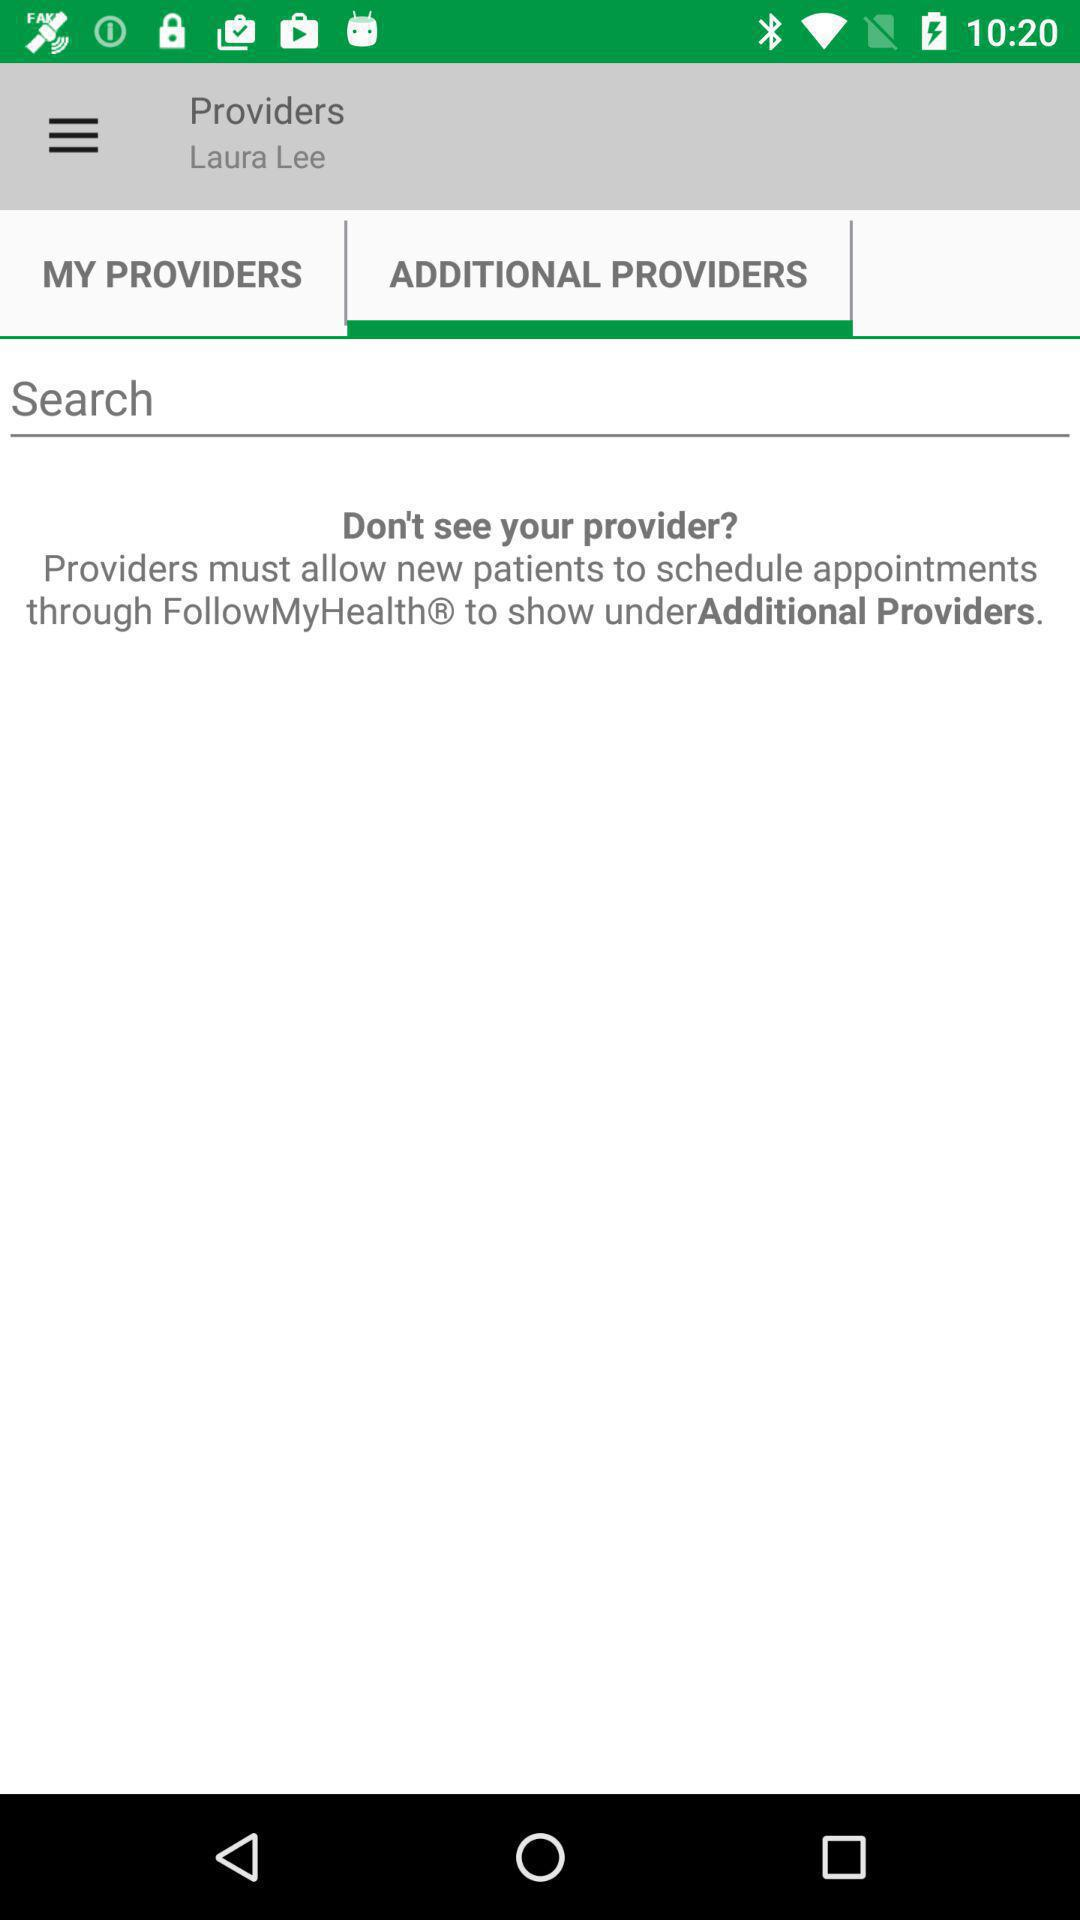Which tab was selected? The selected tab was "ADDITIONAL PROVIDERS". 